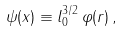Convert formula to latex. <formula><loc_0><loc_0><loc_500><loc_500>\psi ( { x } ) \equiv l _ { 0 } ^ { 3 / 2 } \, \varphi ( { r } ) \, ,</formula> 